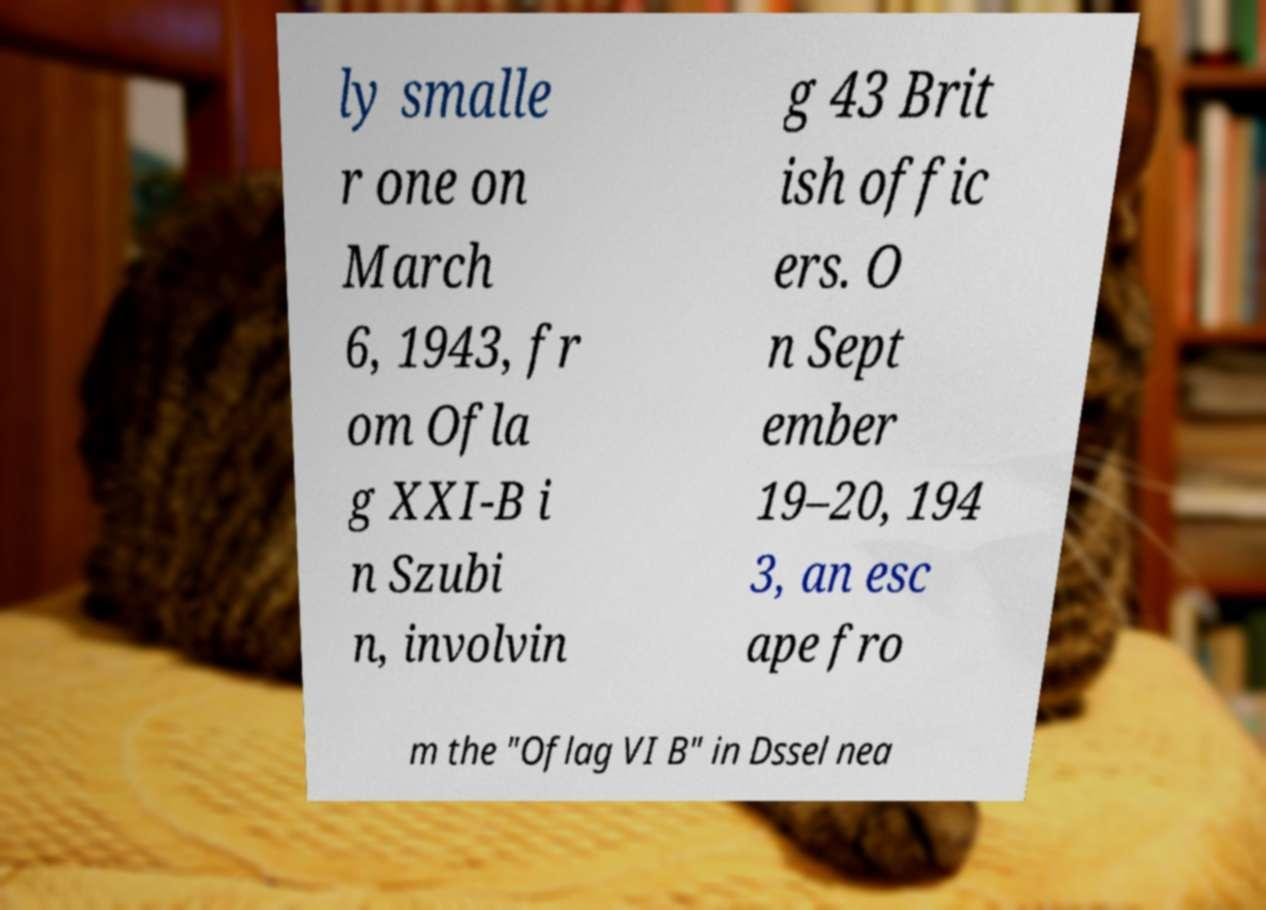Please identify and transcribe the text found in this image. ly smalle r one on March 6, 1943, fr om Ofla g XXI-B i n Szubi n, involvin g 43 Brit ish offic ers. O n Sept ember 19–20, 194 3, an esc ape fro m the "Oflag VI B" in Dssel nea 